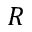Convert formula to latex. <formula><loc_0><loc_0><loc_500><loc_500>R</formula> 